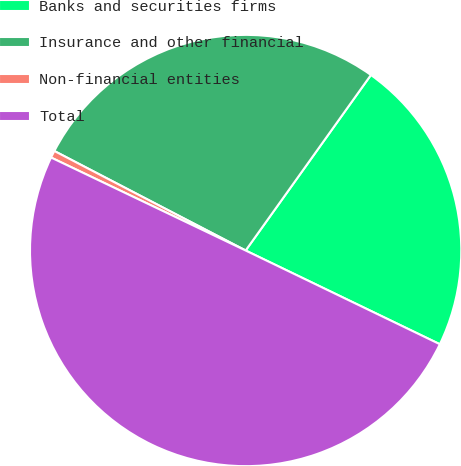Convert chart. <chart><loc_0><loc_0><loc_500><loc_500><pie_chart><fcel>Banks and securities firms<fcel>Insurance and other financial<fcel>Non-financial entities<fcel>Total<nl><fcel>22.29%<fcel>27.23%<fcel>0.54%<fcel>49.94%<nl></chart> 